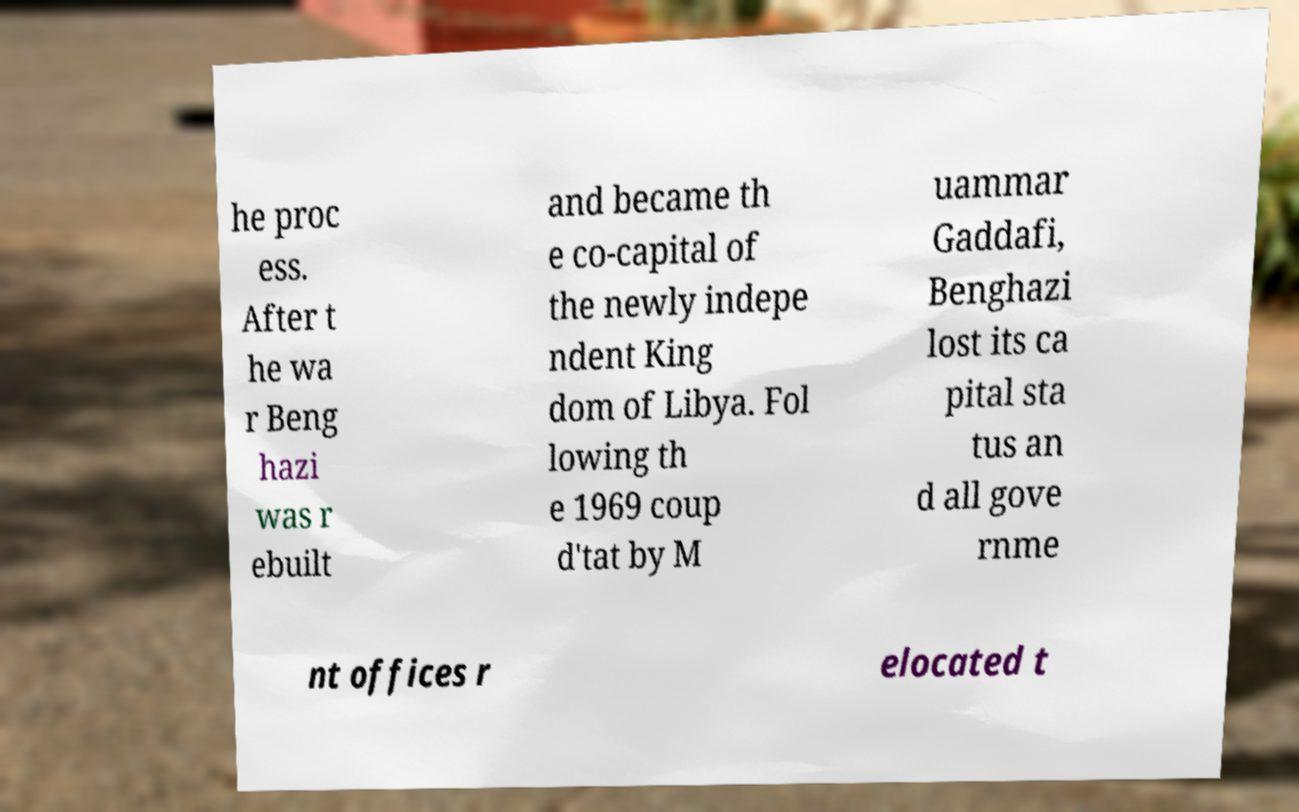Please identify and transcribe the text found in this image. he proc ess. After t he wa r Beng hazi was r ebuilt and became th e co-capital of the newly indepe ndent King dom of Libya. Fol lowing th e 1969 coup d'tat by M uammar Gaddafi, Benghazi lost its ca pital sta tus an d all gove rnme nt offices r elocated t 